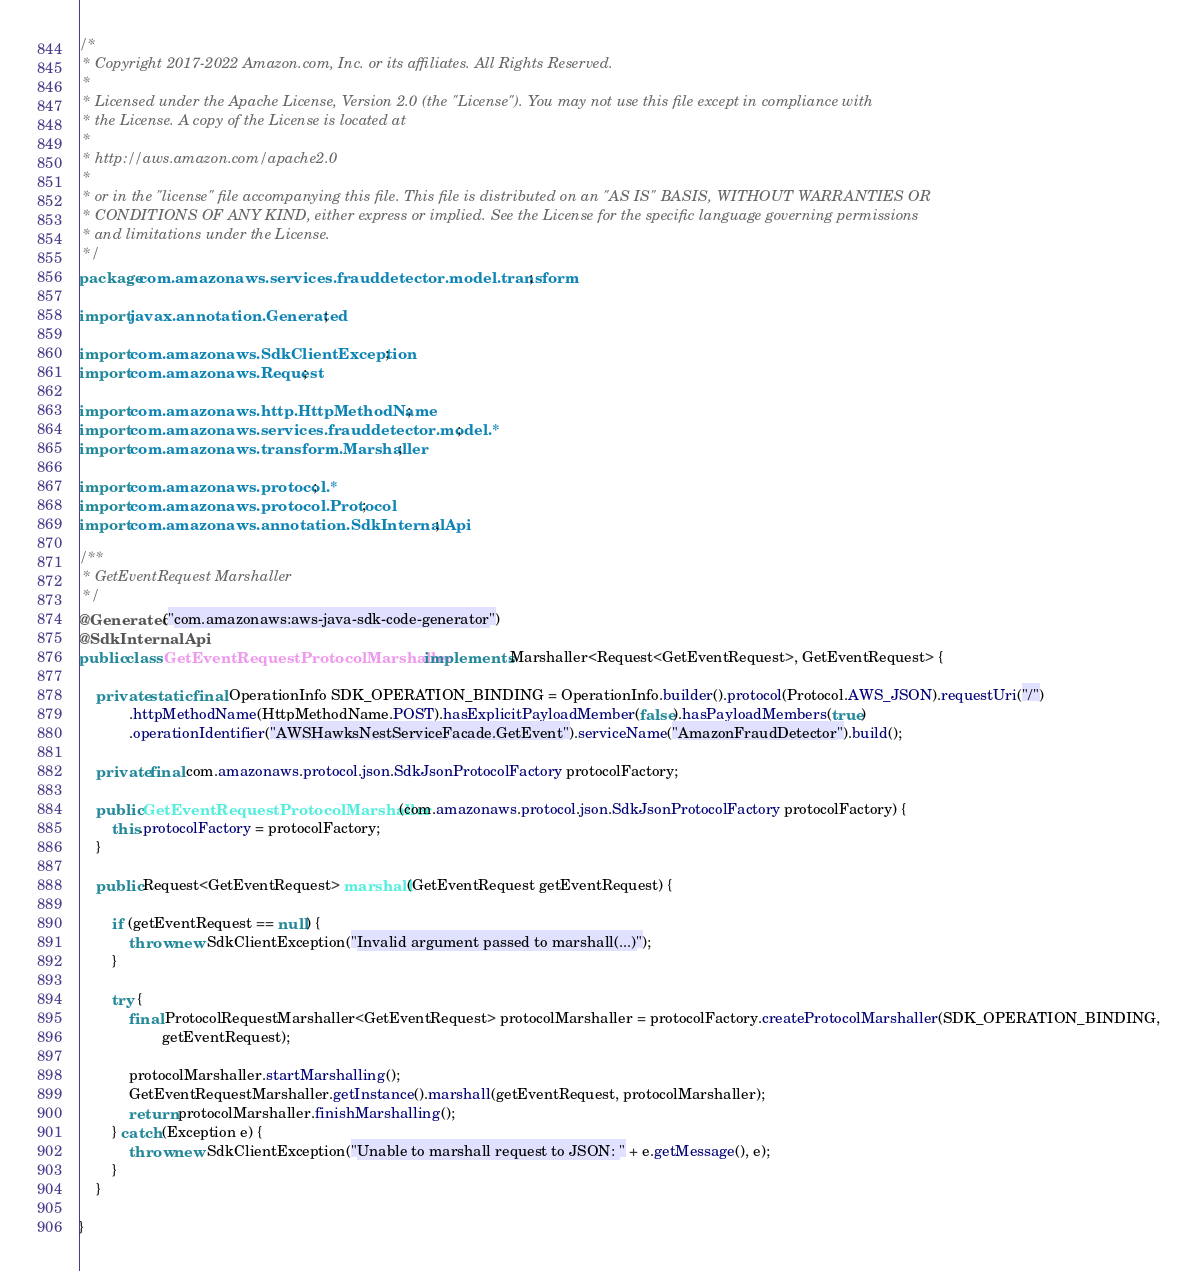Convert code to text. <code><loc_0><loc_0><loc_500><loc_500><_Java_>/*
 * Copyright 2017-2022 Amazon.com, Inc. or its affiliates. All Rights Reserved.
 * 
 * Licensed under the Apache License, Version 2.0 (the "License"). You may not use this file except in compliance with
 * the License. A copy of the License is located at
 * 
 * http://aws.amazon.com/apache2.0
 * 
 * or in the "license" file accompanying this file. This file is distributed on an "AS IS" BASIS, WITHOUT WARRANTIES OR
 * CONDITIONS OF ANY KIND, either express or implied. See the License for the specific language governing permissions
 * and limitations under the License.
 */
package com.amazonaws.services.frauddetector.model.transform;

import javax.annotation.Generated;

import com.amazonaws.SdkClientException;
import com.amazonaws.Request;

import com.amazonaws.http.HttpMethodName;
import com.amazonaws.services.frauddetector.model.*;
import com.amazonaws.transform.Marshaller;

import com.amazonaws.protocol.*;
import com.amazonaws.protocol.Protocol;
import com.amazonaws.annotation.SdkInternalApi;

/**
 * GetEventRequest Marshaller
 */
@Generated("com.amazonaws:aws-java-sdk-code-generator")
@SdkInternalApi
public class GetEventRequestProtocolMarshaller implements Marshaller<Request<GetEventRequest>, GetEventRequest> {

    private static final OperationInfo SDK_OPERATION_BINDING = OperationInfo.builder().protocol(Protocol.AWS_JSON).requestUri("/")
            .httpMethodName(HttpMethodName.POST).hasExplicitPayloadMember(false).hasPayloadMembers(true)
            .operationIdentifier("AWSHawksNestServiceFacade.GetEvent").serviceName("AmazonFraudDetector").build();

    private final com.amazonaws.protocol.json.SdkJsonProtocolFactory protocolFactory;

    public GetEventRequestProtocolMarshaller(com.amazonaws.protocol.json.SdkJsonProtocolFactory protocolFactory) {
        this.protocolFactory = protocolFactory;
    }

    public Request<GetEventRequest> marshall(GetEventRequest getEventRequest) {

        if (getEventRequest == null) {
            throw new SdkClientException("Invalid argument passed to marshall(...)");
        }

        try {
            final ProtocolRequestMarshaller<GetEventRequest> protocolMarshaller = protocolFactory.createProtocolMarshaller(SDK_OPERATION_BINDING,
                    getEventRequest);

            protocolMarshaller.startMarshalling();
            GetEventRequestMarshaller.getInstance().marshall(getEventRequest, protocolMarshaller);
            return protocolMarshaller.finishMarshalling();
        } catch (Exception e) {
            throw new SdkClientException("Unable to marshall request to JSON: " + e.getMessage(), e);
        }
    }

}
</code> 